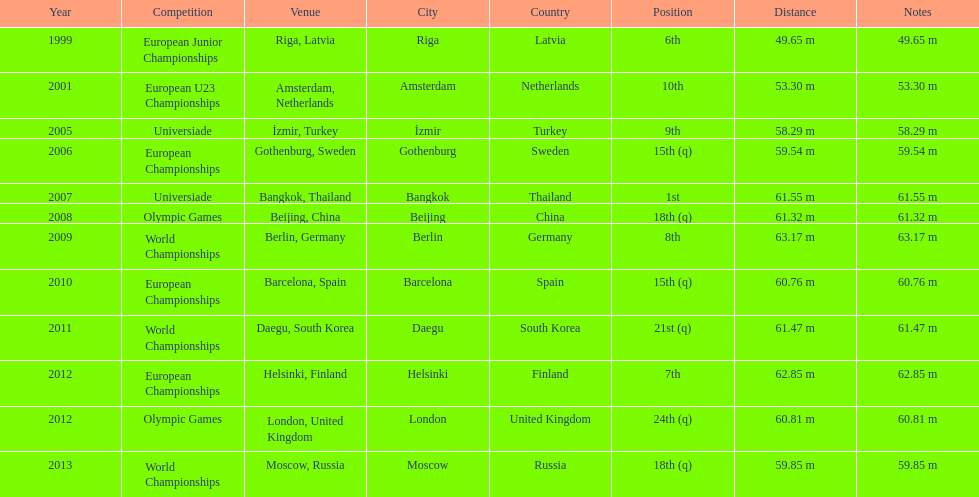Pre-2007, what was the highest rank achieved? 6th. 